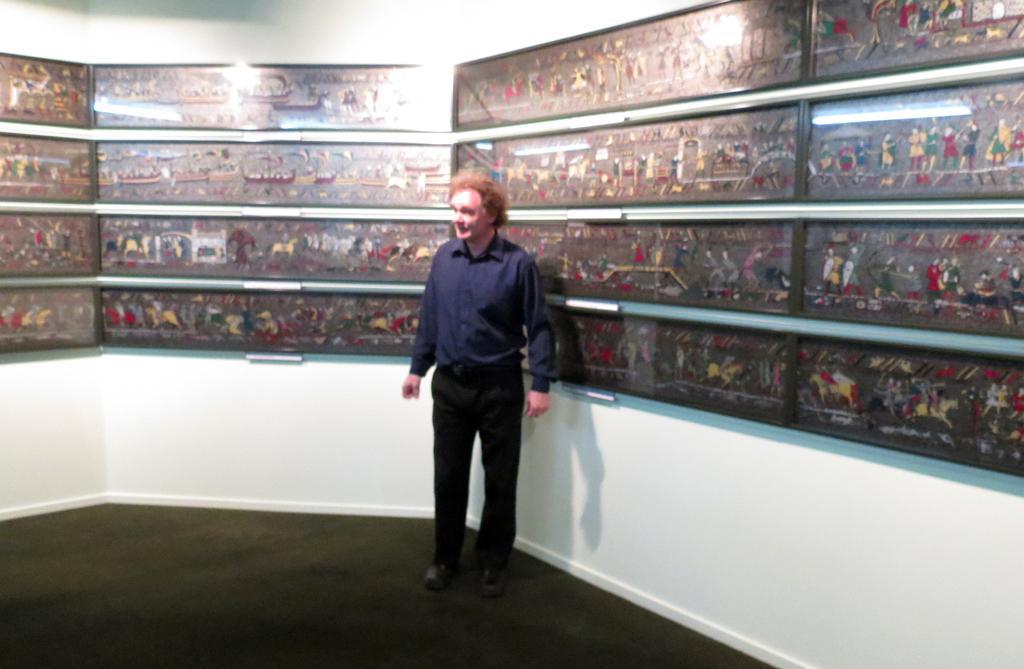Describe this image in one or two sentences. A man is standing at the middle of an image. He wears a blue color shirt and a black color trouser in the right it's a light behind him there are different pictures. 